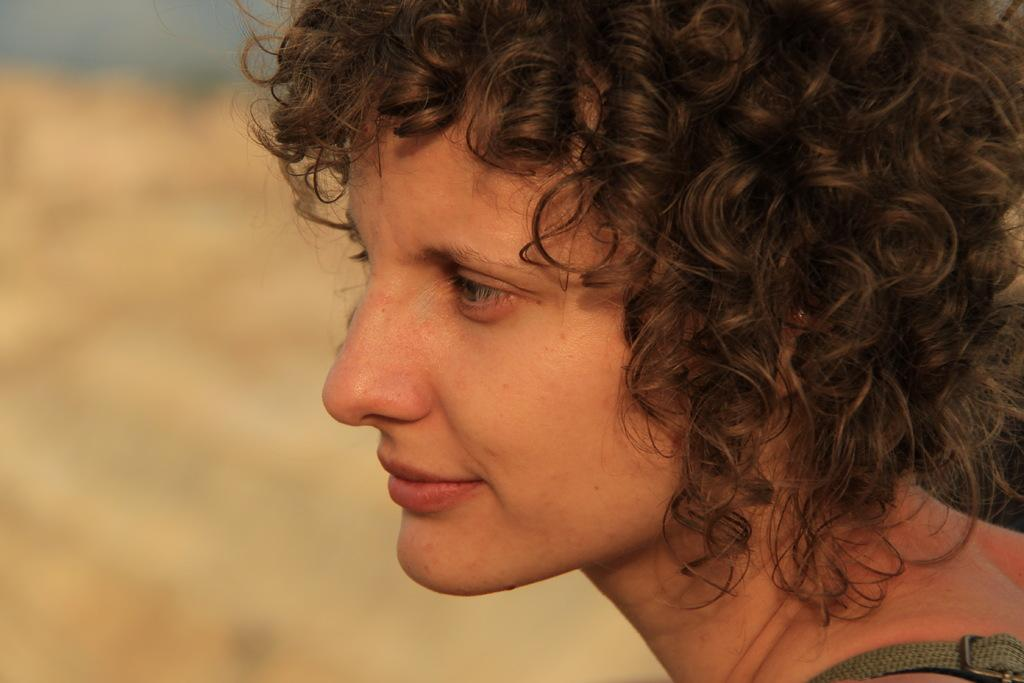Who is the main subject in the foreground of the image? There is a woman in the foreground of the image. Can you describe the woman's hair? The woman has curly hair. What part of the image is blurred? The left side of the image is blurred. What type of creature is sitting on the chair in the image? There is no chair or creature present in the image. 